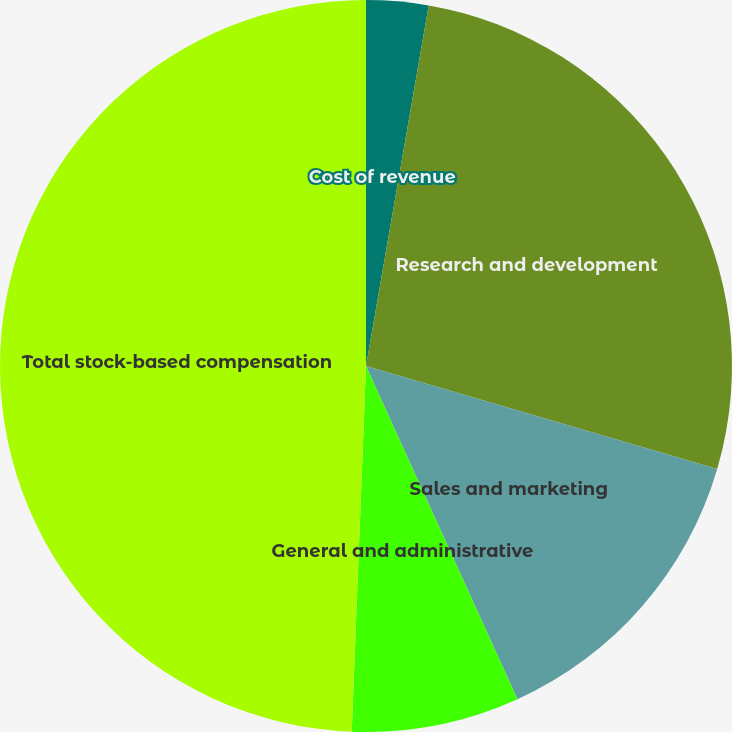Convert chart to OTSL. <chart><loc_0><loc_0><loc_500><loc_500><pie_chart><fcel>Cost of revenue<fcel>Research and development<fcel>Sales and marketing<fcel>General and administrative<fcel>Total stock-based compensation<nl><fcel>2.74%<fcel>26.8%<fcel>13.67%<fcel>7.41%<fcel>49.38%<nl></chart> 